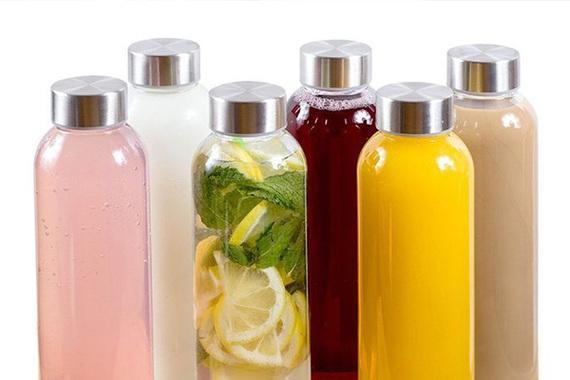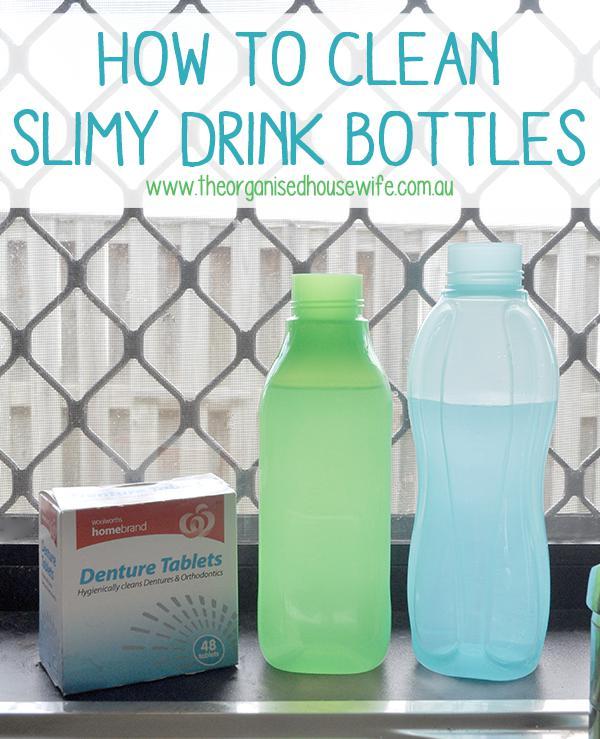The first image is the image on the left, the second image is the image on the right. Assess this claim about the two images: "In at least one image there are at least two plastic bottles with no lids.". Correct or not? Answer yes or no. Yes. 